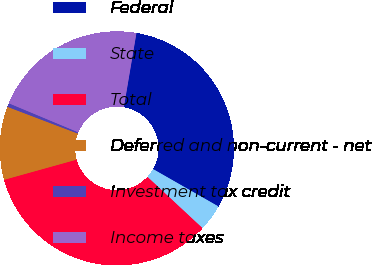Convert chart to OTSL. <chart><loc_0><loc_0><loc_500><loc_500><pie_chart><fcel>Federal<fcel>State<fcel>Total<fcel>Deferred and non-current - net<fcel>Investment tax credit<fcel>Income taxes<nl><fcel>30.59%<fcel>3.67%<fcel>33.74%<fcel>10.1%<fcel>0.52%<fcel>21.37%<nl></chart> 